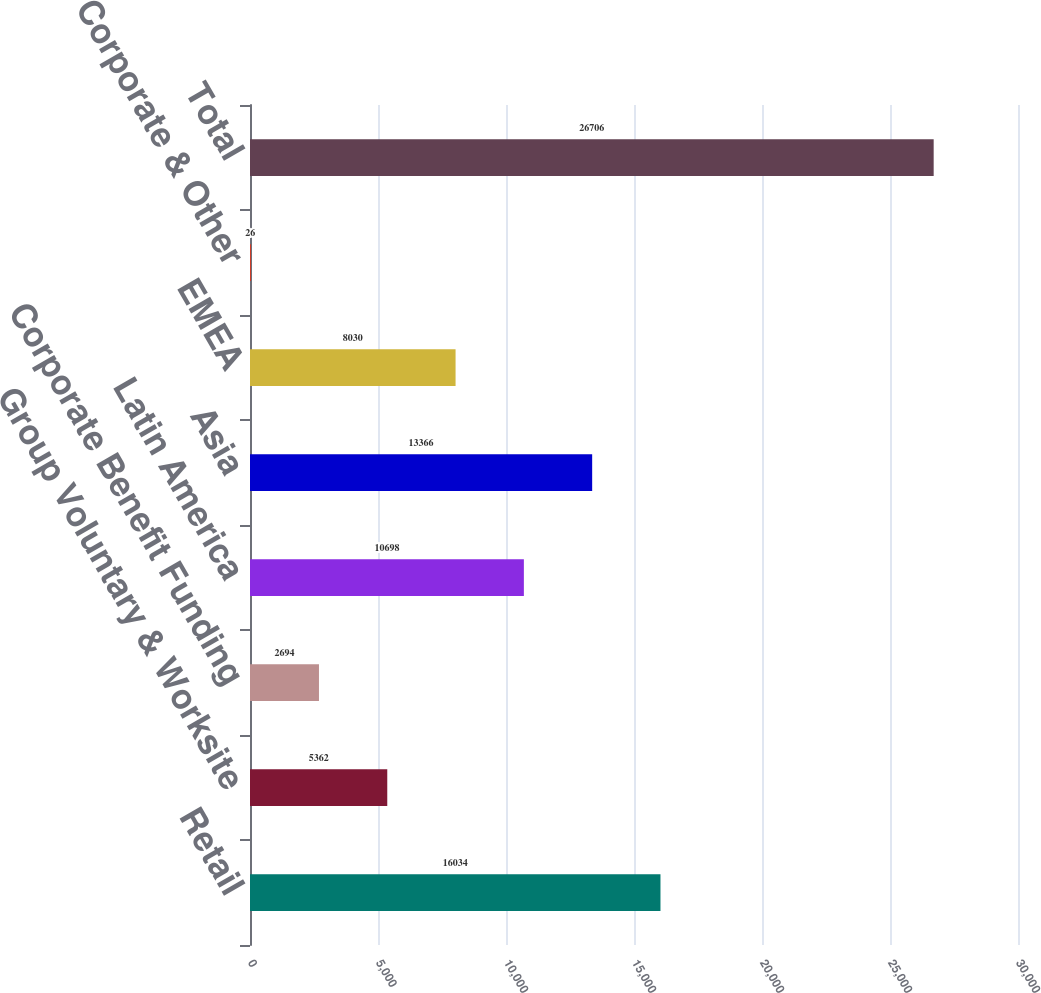Convert chart. <chart><loc_0><loc_0><loc_500><loc_500><bar_chart><fcel>Retail<fcel>Group Voluntary & Worksite<fcel>Corporate Benefit Funding<fcel>Latin America<fcel>Asia<fcel>EMEA<fcel>Corporate & Other<fcel>Total<nl><fcel>16034<fcel>5362<fcel>2694<fcel>10698<fcel>13366<fcel>8030<fcel>26<fcel>26706<nl></chart> 